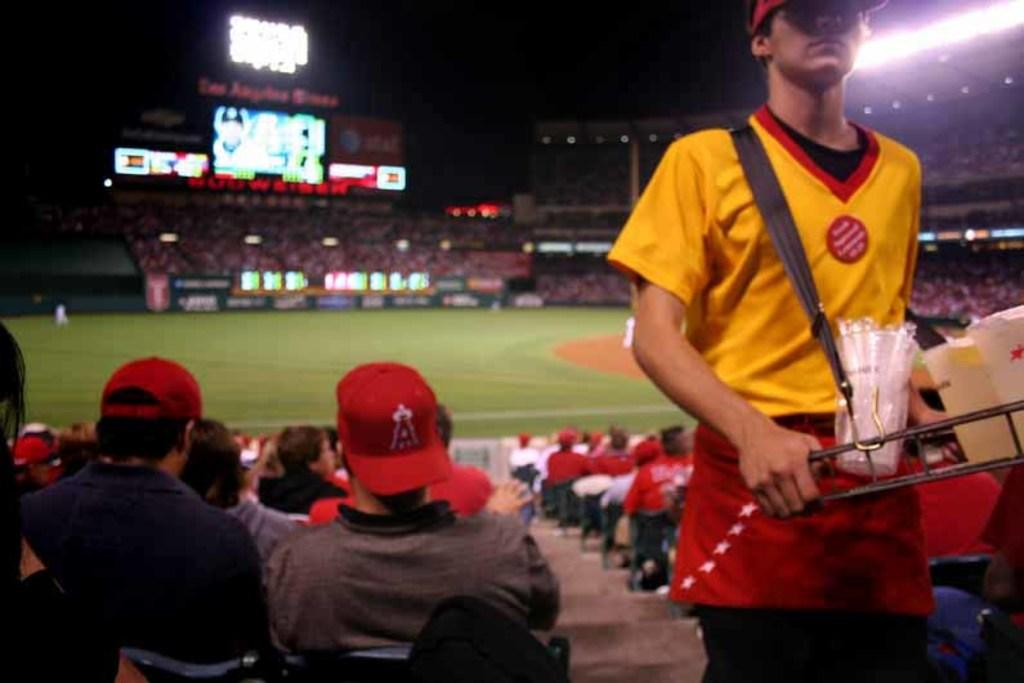<image>
Describe the image concisely. A man in the crowd wears a baseball cap with an A on it. 